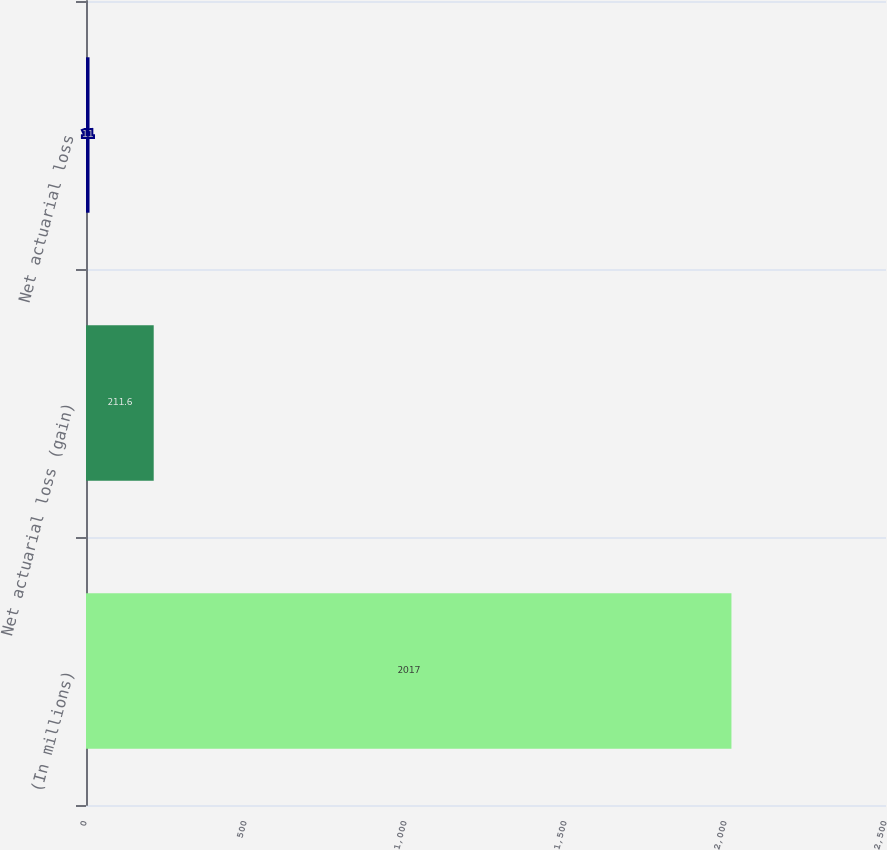Convert chart to OTSL. <chart><loc_0><loc_0><loc_500><loc_500><bar_chart><fcel>(In millions)<fcel>Net actuarial loss (gain)<fcel>Net actuarial loss<nl><fcel>2017<fcel>211.6<fcel>11<nl></chart> 